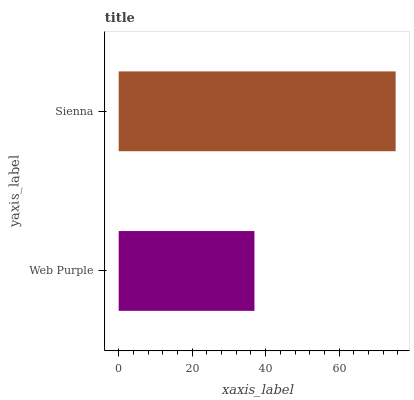Is Web Purple the minimum?
Answer yes or no. Yes. Is Sienna the maximum?
Answer yes or no. Yes. Is Sienna the minimum?
Answer yes or no. No. Is Sienna greater than Web Purple?
Answer yes or no. Yes. Is Web Purple less than Sienna?
Answer yes or no. Yes. Is Web Purple greater than Sienna?
Answer yes or no. No. Is Sienna less than Web Purple?
Answer yes or no. No. Is Sienna the high median?
Answer yes or no. Yes. Is Web Purple the low median?
Answer yes or no. Yes. Is Web Purple the high median?
Answer yes or no. No. Is Sienna the low median?
Answer yes or no. No. 